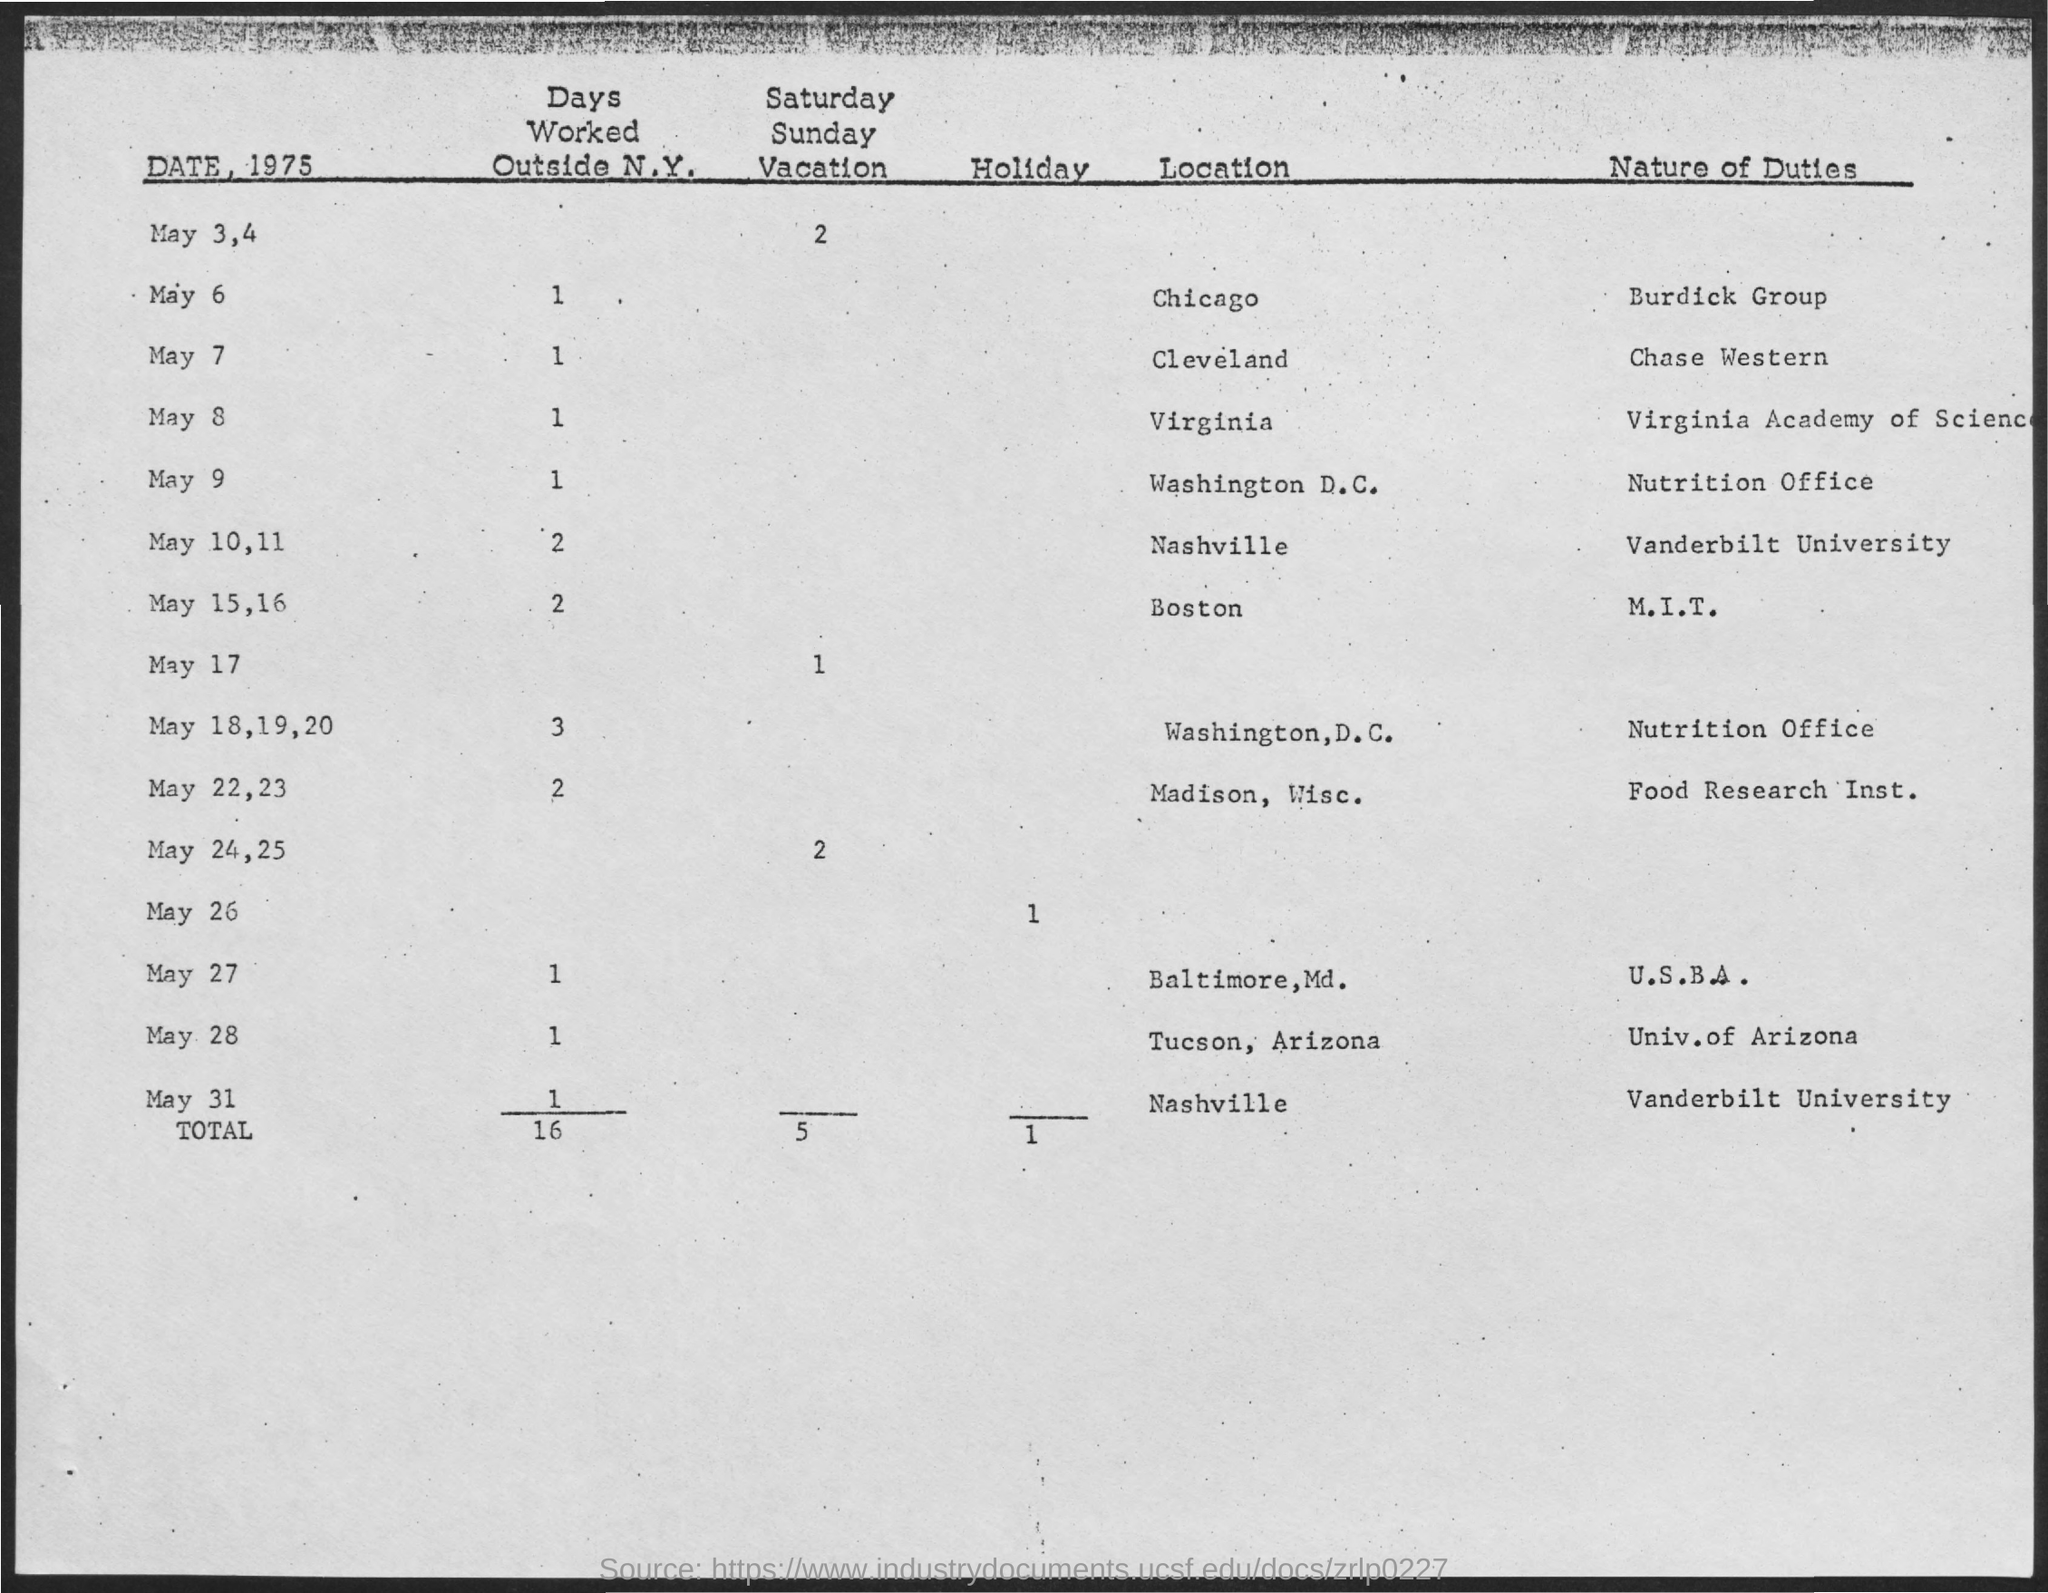Mention a couple of crucial points in this snapshot. The total number of holidays is 1.. On May 7th, the location is Cleveland. On May 6, the location is Chicago. The sentence you provided is a question asking about the number of Saturday-Sunday vacations that occur on May 17th. What is the number of days worked outside New York on May 28th? 